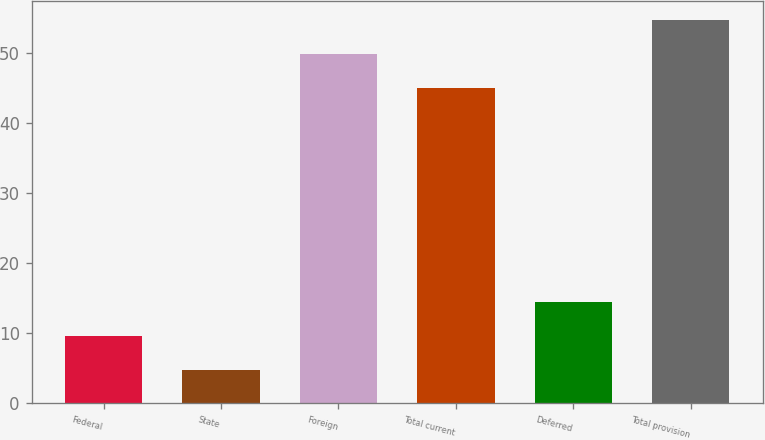<chart> <loc_0><loc_0><loc_500><loc_500><bar_chart><fcel>Federal<fcel>State<fcel>Foreign<fcel>Total current<fcel>Deferred<fcel>Total provision<nl><fcel>9.59<fcel>4.7<fcel>49.79<fcel>44.9<fcel>14.48<fcel>54.68<nl></chart> 